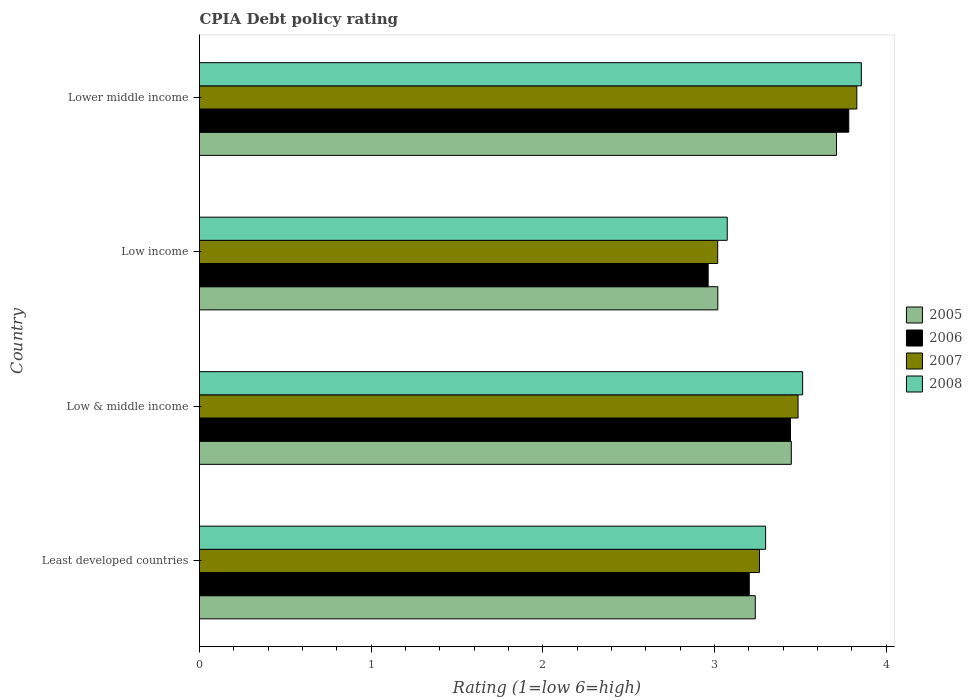Are the number of bars per tick equal to the number of legend labels?
Offer a terse response. Yes. How many bars are there on the 1st tick from the bottom?
Provide a succinct answer. 4. What is the CPIA rating in 2008 in Lower middle income?
Give a very brief answer. 3.86. Across all countries, what is the maximum CPIA rating in 2008?
Your answer should be very brief. 3.86. Across all countries, what is the minimum CPIA rating in 2005?
Your response must be concise. 3.02. In which country was the CPIA rating in 2005 maximum?
Offer a very short reply. Lower middle income. What is the total CPIA rating in 2008 in the graph?
Your answer should be compact. 13.74. What is the difference between the CPIA rating in 2007 in Low & middle income and that in Lower middle income?
Offer a very short reply. -0.34. What is the difference between the CPIA rating in 2008 in Lower middle income and the CPIA rating in 2005 in Low income?
Your answer should be very brief. 0.84. What is the average CPIA rating in 2008 per country?
Your response must be concise. 3.44. What is the difference between the CPIA rating in 2005 and CPIA rating in 2008 in Lower middle income?
Your answer should be very brief. -0.14. In how many countries, is the CPIA rating in 2006 greater than 1.8 ?
Offer a terse response. 4. What is the ratio of the CPIA rating in 2007 in Low income to that in Lower middle income?
Provide a short and direct response. 0.79. What is the difference between the highest and the second highest CPIA rating in 2007?
Provide a short and direct response. 0.34. What is the difference between the highest and the lowest CPIA rating in 2008?
Ensure brevity in your answer.  0.78. In how many countries, is the CPIA rating in 2005 greater than the average CPIA rating in 2005 taken over all countries?
Your answer should be very brief. 2. Is the sum of the CPIA rating in 2005 in Least developed countries and Low & middle income greater than the maximum CPIA rating in 2006 across all countries?
Your answer should be very brief. Yes. Is it the case that in every country, the sum of the CPIA rating in 2005 and CPIA rating in 2007 is greater than the sum of CPIA rating in 2006 and CPIA rating in 2008?
Give a very brief answer. No. What does the 1st bar from the top in Lower middle income represents?
Give a very brief answer. 2008. What does the 3rd bar from the bottom in Lower middle income represents?
Ensure brevity in your answer.  2007. How many bars are there?
Make the answer very short. 16. Are all the bars in the graph horizontal?
Give a very brief answer. Yes. How many countries are there in the graph?
Offer a very short reply. 4. What is the difference between two consecutive major ticks on the X-axis?
Provide a short and direct response. 1. Does the graph contain grids?
Your response must be concise. No. Where does the legend appear in the graph?
Your answer should be very brief. Center right. How many legend labels are there?
Provide a succinct answer. 4. What is the title of the graph?
Ensure brevity in your answer.  CPIA Debt policy rating. Does "1988" appear as one of the legend labels in the graph?
Give a very brief answer. No. What is the Rating (1=low 6=high) of 2005 in Least developed countries?
Keep it short and to the point. 3.24. What is the Rating (1=low 6=high) of 2006 in Least developed countries?
Keep it short and to the point. 3.2. What is the Rating (1=low 6=high) of 2007 in Least developed countries?
Your answer should be compact. 3.26. What is the Rating (1=low 6=high) of 2008 in Least developed countries?
Your answer should be compact. 3.3. What is the Rating (1=low 6=high) of 2005 in Low & middle income?
Ensure brevity in your answer.  3.45. What is the Rating (1=low 6=high) in 2006 in Low & middle income?
Your answer should be compact. 3.44. What is the Rating (1=low 6=high) in 2007 in Low & middle income?
Your response must be concise. 3.49. What is the Rating (1=low 6=high) in 2008 in Low & middle income?
Your response must be concise. 3.51. What is the Rating (1=low 6=high) of 2005 in Low income?
Offer a terse response. 3.02. What is the Rating (1=low 6=high) in 2006 in Low income?
Offer a terse response. 2.96. What is the Rating (1=low 6=high) in 2007 in Low income?
Offer a terse response. 3.02. What is the Rating (1=low 6=high) of 2008 in Low income?
Provide a succinct answer. 3.07. What is the Rating (1=low 6=high) in 2005 in Lower middle income?
Your response must be concise. 3.71. What is the Rating (1=low 6=high) in 2006 in Lower middle income?
Your response must be concise. 3.78. What is the Rating (1=low 6=high) in 2007 in Lower middle income?
Make the answer very short. 3.83. What is the Rating (1=low 6=high) of 2008 in Lower middle income?
Ensure brevity in your answer.  3.86. Across all countries, what is the maximum Rating (1=low 6=high) in 2005?
Give a very brief answer. 3.71. Across all countries, what is the maximum Rating (1=low 6=high) in 2006?
Offer a very short reply. 3.78. Across all countries, what is the maximum Rating (1=low 6=high) in 2007?
Offer a terse response. 3.83. Across all countries, what is the maximum Rating (1=low 6=high) in 2008?
Give a very brief answer. 3.86. Across all countries, what is the minimum Rating (1=low 6=high) of 2005?
Give a very brief answer. 3.02. Across all countries, what is the minimum Rating (1=low 6=high) in 2006?
Offer a very short reply. 2.96. Across all countries, what is the minimum Rating (1=low 6=high) in 2007?
Give a very brief answer. 3.02. Across all countries, what is the minimum Rating (1=low 6=high) in 2008?
Provide a short and direct response. 3.07. What is the total Rating (1=low 6=high) of 2005 in the graph?
Offer a terse response. 13.41. What is the total Rating (1=low 6=high) of 2006 in the graph?
Keep it short and to the point. 13.39. What is the total Rating (1=low 6=high) of 2007 in the graph?
Your answer should be very brief. 13.6. What is the total Rating (1=low 6=high) of 2008 in the graph?
Your answer should be compact. 13.74. What is the difference between the Rating (1=low 6=high) in 2005 in Least developed countries and that in Low & middle income?
Your response must be concise. -0.21. What is the difference between the Rating (1=low 6=high) in 2006 in Least developed countries and that in Low & middle income?
Offer a very short reply. -0.24. What is the difference between the Rating (1=low 6=high) of 2007 in Least developed countries and that in Low & middle income?
Offer a very short reply. -0.22. What is the difference between the Rating (1=low 6=high) in 2008 in Least developed countries and that in Low & middle income?
Offer a terse response. -0.22. What is the difference between the Rating (1=low 6=high) of 2005 in Least developed countries and that in Low income?
Ensure brevity in your answer.  0.22. What is the difference between the Rating (1=low 6=high) in 2006 in Least developed countries and that in Low income?
Your response must be concise. 0.24. What is the difference between the Rating (1=low 6=high) in 2007 in Least developed countries and that in Low income?
Provide a succinct answer. 0.24. What is the difference between the Rating (1=low 6=high) of 2008 in Least developed countries and that in Low income?
Provide a succinct answer. 0.22. What is the difference between the Rating (1=low 6=high) of 2005 in Least developed countries and that in Lower middle income?
Provide a short and direct response. -0.47. What is the difference between the Rating (1=low 6=high) in 2006 in Least developed countries and that in Lower middle income?
Offer a very short reply. -0.58. What is the difference between the Rating (1=low 6=high) of 2007 in Least developed countries and that in Lower middle income?
Give a very brief answer. -0.57. What is the difference between the Rating (1=low 6=high) in 2008 in Least developed countries and that in Lower middle income?
Your answer should be very brief. -0.56. What is the difference between the Rating (1=low 6=high) in 2005 in Low & middle income and that in Low income?
Offer a very short reply. 0.43. What is the difference between the Rating (1=low 6=high) in 2006 in Low & middle income and that in Low income?
Provide a short and direct response. 0.48. What is the difference between the Rating (1=low 6=high) in 2007 in Low & middle income and that in Low income?
Make the answer very short. 0.47. What is the difference between the Rating (1=low 6=high) in 2008 in Low & middle income and that in Low income?
Keep it short and to the point. 0.44. What is the difference between the Rating (1=low 6=high) of 2005 in Low & middle income and that in Lower middle income?
Your response must be concise. -0.26. What is the difference between the Rating (1=low 6=high) of 2006 in Low & middle income and that in Lower middle income?
Your response must be concise. -0.34. What is the difference between the Rating (1=low 6=high) in 2007 in Low & middle income and that in Lower middle income?
Your response must be concise. -0.34. What is the difference between the Rating (1=low 6=high) of 2008 in Low & middle income and that in Lower middle income?
Make the answer very short. -0.34. What is the difference between the Rating (1=low 6=high) in 2005 in Low income and that in Lower middle income?
Your response must be concise. -0.69. What is the difference between the Rating (1=low 6=high) of 2006 in Low income and that in Lower middle income?
Offer a terse response. -0.82. What is the difference between the Rating (1=low 6=high) of 2007 in Low income and that in Lower middle income?
Offer a very short reply. -0.81. What is the difference between the Rating (1=low 6=high) of 2008 in Low income and that in Lower middle income?
Offer a terse response. -0.78. What is the difference between the Rating (1=low 6=high) in 2005 in Least developed countries and the Rating (1=low 6=high) in 2006 in Low & middle income?
Ensure brevity in your answer.  -0.2. What is the difference between the Rating (1=low 6=high) of 2005 in Least developed countries and the Rating (1=low 6=high) of 2007 in Low & middle income?
Ensure brevity in your answer.  -0.25. What is the difference between the Rating (1=low 6=high) of 2005 in Least developed countries and the Rating (1=low 6=high) of 2008 in Low & middle income?
Make the answer very short. -0.28. What is the difference between the Rating (1=low 6=high) of 2006 in Least developed countries and the Rating (1=low 6=high) of 2007 in Low & middle income?
Your answer should be very brief. -0.28. What is the difference between the Rating (1=low 6=high) of 2006 in Least developed countries and the Rating (1=low 6=high) of 2008 in Low & middle income?
Your answer should be very brief. -0.31. What is the difference between the Rating (1=low 6=high) in 2007 in Least developed countries and the Rating (1=low 6=high) in 2008 in Low & middle income?
Offer a very short reply. -0.25. What is the difference between the Rating (1=low 6=high) in 2005 in Least developed countries and the Rating (1=low 6=high) in 2006 in Low income?
Provide a succinct answer. 0.27. What is the difference between the Rating (1=low 6=high) in 2005 in Least developed countries and the Rating (1=low 6=high) in 2007 in Low income?
Make the answer very short. 0.22. What is the difference between the Rating (1=low 6=high) of 2005 in Least developed countries and the Rating (1=low 6=high) of 2008 in Low income?
Offer a very short reply. 0.16. What is the difference between the Rating (1=low 6=high) in 2006 in Least developed countries and the Rating (1=low 6=high) in 2007 in Low income?
Provide a short and direct response. 0.18. What is the difference between the Rating (1=low 6=high) of 2006 in Least developed countries and the Rating (1=low 6=high) of 2008 in Low income?
Ensure brevity in your answer.  0.13. What is the difference between the Rating (1=low 6=high) in 2007 in Least developed countries and the Rating (1=low 6=high) in 2008 in Low income?
Your answer should be very brief. 0.19. What is the difference between the Rating (1=low 6=high) of 2005 in Least developed countries and the Rating (1=low 6=high) of 2006 in Lower middle income?
Offer a terse response. -0.54. What is the difference between the Rating (1=low 6=high) of 2005 in Least developed countries and the Rating (1=low 6=high) of 2007 in Lower middle income?
Provide a short and direct response. -0.59. What is the difference between the Rating (1=low 6=high) of 2005 in Least developed countries and the Rating (1=low 6=high) of 2008 in Lower middle income?
Provide a succinct answer. -0.62. What is the difference between the Rating (1=low 6=high) of 2006 in Least developed countries and the Rating (1=low 6=high) of 2007 in Lower middle income?
Provide a short and direct response. -0.63. What is the difference between the Rating (1=low 6=high) in 2006 in Least developed countries and the Rating (1=low 6=high) in 2008 in Lower middle income?
Ensure brevity in your answer.  -0.65. What is the difference between the Rating (1=low 6=high) of 2007 in Least developed countries and the Rating (1=low 6=high) of 2008 in Lower middle income?
Ensure brevity in your answer.  -0.59. What is the difference between the Rating (1=low 6=high) of 2005 in Low & middle income and the Rating (1=low 6=high) of 2006 in Low income?
Give a very brief answer. 0.48. What is the difference between the Rating (1=low 6=high) in 2005 in Low & middle income and the Rating (1=low 6=high) in 2007 in Low income?
Make the answer very short. 0.43. What is the difference between the Rating (1=low 6=high) of 2005 in Low & middle income and the Rating (1=low 6=high) of 2008 in Low income?
Make the answer very short. 0.37. What is the difference between the Rating (1=low 6=high) of 2006 in Low & middle income and the Rating (1=low 6=high) of 2007 in Low income?
Ensure brevity in your answer.  0.42. What is the difference between the Rating (1=low 6=high) of 2006 in Low & middle income and the Rating (1=low 6=high) of 2008 in Low income?
Give a very brief answer. 0.37. What is the difference between the Rating (1=low 6=high) in 2007 in Low & middle income and the Rating (1=low 6=high) in 2008 in Low income?
Your response must be concise. 0.41. What is the difference between the Rating (1=low 6=high) in 2005 in Low & middle income and the Rating (1=low 6=high) in 2006 in Lower middle income?
Your answer should be very brief. -0.33. What is the difference between the Rating (1=low 6=high) of 2005 in Low & middle income and the Rating (1=low 6=high) of 2007 in Lower middle income?
Provide a short and direct response. -0.38. What is the difference between the Rating (1=low 6=high) of 2005 in Low & middle income and the Rating (1=low 6=high) of 2008 in Lower middle income?
Make the answer very short. -0.41. What is the difference between the Rating (1=low 6=high) of 2006 in Low & middle income and the Rating (1=low 6=high) of 2007 in Lower middle income?
Provide a short and direct response. -0.39. What is the difference between the Rating (1=low 6=high) of 2006 in Low & middle income and the Rating (1=low 6=high) of 2008 in Lower middle income?
Provide a succinct answer. -0.41. What is the difference between the Rating (1=low 6=high) in 2007 in Low & middle income and the Rating (1=low 6=high) in 2008 in Lower middle income?
Provide a short and direct response. -0.37. What is the difference between the Rating (1=low 6=high) in 2005 in Low income and the Rating (1=low 6=high) in 2006 in Lower middle income?
Offer a terse response. -0.76. What is the difference between the Rating (1=low 6=high) of 2005 in Low income and the Rating (1=low 6=high) of 2007 in Lower middle income?
Ensure brevity in your answer.  -0.81. What is the difference between the Rating (1=low 6=high) in 2005 in Low income and the Rating (1=low 6=high) in 2008 in Lower middle income?
Your answer should be compact. -0.84. What is the difference between the Rating (1=low 6=high) in 2006 in Low income and the Rating (1=low 6=high) in 2007 in Lower middle income?
Your answer should be compact. -0.87. What is the difference between the Rating (1=low 6=high) in 2006 in Low income and the Rating (1=low 6=high) in 2008 in Lower middle income?
Keep it short and to the point. -0.89. What is the difference between the Rating (1=low 6=high) in 2007 in Low income and the Rating (1=low 6=high) in 2008 in Lower middle income?
Offer a terse response. -0.84. What is the average Rating (1=low 6=high) of 2005 per country?
Your answer should be very brief. 3.35. What is the average Rating (1=low 6=high) of 2006 per country?
Give a very brief answer. 3.35. What is the average Rating (1=low 6=high) in 2007 per country?
Offer a terse response. 3.4. What is the average Rating (1=low 6=high) of 2008 per country?
Ensure brevity in your answer.  3.44. What is the difference between the Rating (1=low 6=high) of 2005 and Rating (1=low 6=high) of 2006 in Least developed countries?
Give a very brief answer. 0.04. What is the difference between the Rating (1=low 6=high) in 2005 and Rating (1=low 6=high) in 2007 in Least developed countries?
Offer a terse response. -0.02. What is the difference between the Rating (1=low 6=high) in 2005 and Rating (1=low 6=high) in 2008 in Least developed countries?
Give a very brief answer. -0.06. What is the difference between the Rating (1=low 6=high) of 2006 and Rating (1=low 6=high) of 2007 in Least developed countries?
Give a very brief answer. -0.06. What is the difference between the Rating (1=low 6=high) of 2006 and Rating (1=low 6=high) of 2008 in Least developed countries?
Ensure brevity in your answer.  -0.1. What is the difference between the Rating (1=low 6=high) of 2007 and Rating (1=low 6=high) of 2008 in Least developed countries?
Provide a succinct answer. -0.04. What is the difference between the Rating (1=low 6=high) in 2005 and Rating (1=low 6=high) in 2006 in Low & middle income?
Make the answer very short. 0.01. What is the difference between the Rating (1=low 6=high) in 2005 and Rating (1=low 6=high) in 2007 in Low & middle income?
Make the answer very short. -0.04. What is the difference between the Rating (1=low 6=high) of 2005 and Rating (1=low 6=high) of 2008 in Low & middle income?
Make the answer very short. -0.07. What is the difference between the Rating (1=low 6=high) of 2006 and Rating (1=low 6=high) of 2007 in Low & middle income?
Offer a terse response. -0.04. What is the difference between the Rating (1=low 6=high) in 2006 and Rating (1=low 6=high) in 2008 in Low & middle income?
Offer a very short reply. -0.07. What is the difference between the Rating (1=low 6=high) in 2007 and Rating (1=low 6=high) in 2008 in Low & middle income?
Keep it short and to the point. -0.03. What is the difference between the Rating (1=low 6=high) in 2005 and Rating (1=low 6=high) in 2006 in Low income?
Offer a terse response. 0.06. What is the difference between the Rating (1=low 6=high) in 2005 and Rating (1=low 6=high) in 2007 in Low income?
Ensure brevity in your answer.  0. What is the difference between the Rating (1=low 6=high) in 2005 and Rating (1=low 6=high) in 2008 in Low income?
Your response must be concise. -0.05. What is the difference between the Rating (1=low 6=high) of 2006 and Rating (1=low 6=high) of 2007 in Low income?
Provide a short and direct response. -0.06. What is the difference between the Rating (1=low 6=high) of 2006 and Rating (1=low 6=high) of 2008 in Low income?
Keep it short and to the point. -0.11. What is the difference between the Rating (1=low 6=high) in 2007 and Rating (1=low 6=high) in 2008 in Low income?
Your response must be concise. -0.06. What is the difference between the Rating (1=low 6=high) of 2005 and Rating (1=low 6=high) of 2006 in Lower middle income?
Provide a short and direct response. -0.07. What is the difference between the Rating (1=low 6=high) of 2005 and Rating (1=low 6=high) of 2007 in Lower middle income?
Ensure brevity in your answer.  -0.12. What is the difference between the Rating (1=low 6=high) of 2005 and Rating (1=low 6=high) of 2008 in Lower middle income?
Give a very brief answer. -0.14. What is the difference between the Rating (1=low 6=high) in 2006 and Rating (1=low 6=high) in 2007 in Lower middle income?
Provide a short and direct response. -0.05. What is the difference between the Rating (1=low 6=high) of 2006 and Rating (1=low 6=high) of 2008 in Lower middle income?
Your answer should be compact. -0.07. What is the difference between the Rating (1=low 6=high) in 2007 and Rating (1=low 6=high) in 2008 in Lower middle income?
Ensure brevity in your answer.  -0.03. What is the ratio of the Rating (1=low 6=high) in 2005 in Least developed countries to that in Low & middle income?
Give a very brief answer. 0.94. What is the ratio of the Rating (1=low 6=high) of 2006 in Least developed countries to that in Low & middle income?
Ensure brevity in your answer.  0.93. What is the ratio of the Rating (1=low 6=high) in 2007 in Least developed countries to that in Low & middle income?
Give a very brief answer. 0.94. What is the ratio of the Rating (1=low 6=high) in 2008 in Least developed countries to that in Low & middle income?
Offer a very short reply. 0.94. What is the ratio of the Rating (1=low 6=high) in 2005 in Least developed countries to that in Low income?
Keep it short and to the point. 1.07. What is the ratio of the Rating (1=low 6=high) of 2006 in Least developed countries to that in Low income?
Provide a short and direct response. 1.08. What is the ratio of the Rating (1=low 6=high) in 2007 in Least developed countries to that in Low income?
Your response must be concise. 1.08. What is the ratio of the Rating (1=low 6=high) in 2008 in Least developed countries to that in Low income?
Ensure brevity in your answer.  1.07. What is the ratio of the Rating (1=low 6=high) of 2005 in Least developed countries to that in Lower middle income?
Your answer should be compact. 0.87. What is the ratio of the Rating (1=low 6=high) of 2006 in Least developed countries to that in Lower middle income?
Make the answer very short. 0.85. What is the ratio of the Rating (1=low 6=high) of 2007 in Least developed countries to that in Lower middle income?
Offer a terse response. 0.85. What is the ratio of the Rating (1=low 6=high) in 2008 in Least developed countries to that in Lower middle income?
Keep it short and to the point. 0.86. What is the ratio of the Rating (1=low 6=high) in 2005 in Low & middle income to that in Low income?
Give a very brief answer. 1.14. What is the ratio of the Rating (1=low 6=high) in 2006 in Low & middle income to that in Low income?
Provide a succinct answer. 1.16. What is the ratio of the Rating (1=low 6=high) in 2007 in Low & middle income to that in Low income?
Your answer should be very brief. 1.16. What is the ratio of the Rating (1=low 6=high) of 2005 in Low & middle income to that in Lower middle income?
Ensure brevity in your answer.  0.93. What is the ratio of the Rating (1=low 6=high) of 2006 in Low & middle income to that in Lower middle income?
Provide a succinct answer. 0.91. What is the ratio of the Rating (1=low 6=high) of 2007 in Low & middle income to that in Lower middle income?
Provide a succinct answer. 0.91. What is the ratio of the Rating (1=low 6=high) in 2008 in Low & middle income to that in Lower middle income?
Your answer should be very brief. 0.91. What is the ratio of the Rating (1=low 6=high) of 2005 in Low income to that in Lower middle income?
Make the answer very short. 0.81. What is the ratio of the Rating (1=low 6=high) of 2006 in Low income to that in Lower middle income?
Make the answer very short. 0.78. What is the ratio of the Rating (1=low 6=high) of 2007 in Low income to that in Lower middle income?
Your answer should be very brief. 0.79. What is the ratio of the Rating (1=low 6=high) in 2008 in Low income to that in Lower middle income?
Provide a succinct answer. 0.8. What is the difference between the highest and the second highest Rating (1=low 6=high) in 2005?
Your answer should be compact. 0.26. What is the difference between the highest and the second highest Rating (1=low 6=high) of 2006?
Offer a very short reply. 0.34. What is the difference between the highest and the second highest Rating (1=low 6=high) of 2007?
Your response must be concise. 0.34. What is the difference between the highest and the second highest Rating (1=low 6=high) in 2008?
Offer a very short reply. 0.34. What is the difference between the highest and the lowest Rating (1=low 6=high) in 2005?
Make the answer very short. 0.69. What is the difference between the highest and the lowest Rating (1=low 6=high) in 2006?
Ensure brevity in your answer.  0.82. What is the difference between the highest and the lowest Rating (1=low 6=high) of 2007?
Make the answer very short. 0.81. What is the difference between the highest and the lowest Rating (1=low 6=high) of 2008?
Keep it short and to the point. 0.78. 